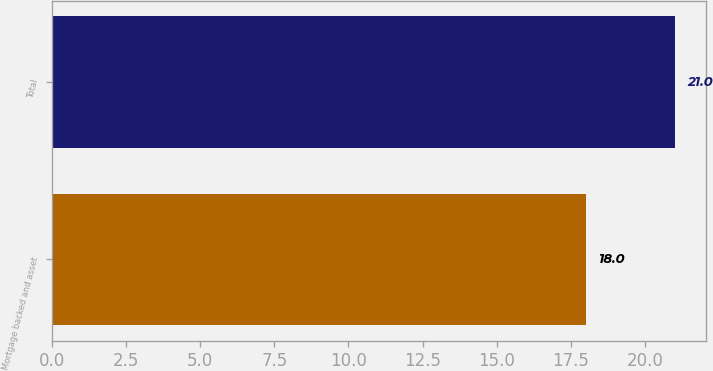Convert chart. <chart><loc_0><loc_0><loc_500><loc_500><bar_chart><fcel>Mortgage backed and asset<fcel>Total<nl><fcel>18<fcel>21<nl></chart> 